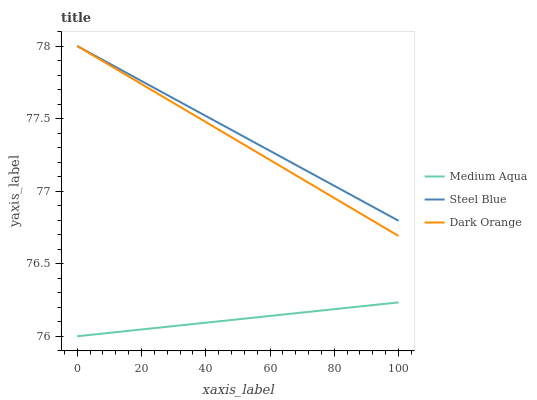Does Medium Aqua have the minimum area under the curve?
Answer yes or no. Yes. Does Steel Blue have the maximum area under the curve?
Answer yes or no. Yes. Does Steel Blue have the minimum area under the curve?
Answer yes or no. No. Does Medium Aqua have the maximum area under the curve?
Answer yes or no. No. Is Medium Aqua the smoothest?
Answer yes or no. Yes. Is Steel Blue the roughest?
Answer yes or no. Yes. Is Steel Blue the smoothest?
Answer yes or no. No. Is Medium Aqua the roughest?
Answer yes or no. No. Does Medium Aqua have the lowest value?
Answer yes or no. Yes. Does Steel Blue have the lowest value?
Answer yes or no. No. Does Steel Blue have the highest value?
Answer yes or no. Yes. Does Medium Aqua have the highest value?
Answer yes or no. No. Is Medium Aqua less than Steel Blue?
Answer yes or no. Yes. Is Dark Orange greater than Medium Aqua?
Answer yes or no. Yes. Does Dark Orange intersect Steel Blue?
Answer yes or no. Yes. Is Dark Orange less than Steel Blue?
Answer yes or no. No. Is Dark Orange greater than Steel Blue?
Answer yes or no. No. Does Medium Aqua intersect Steel Blue?
Answer yes or no. No. 